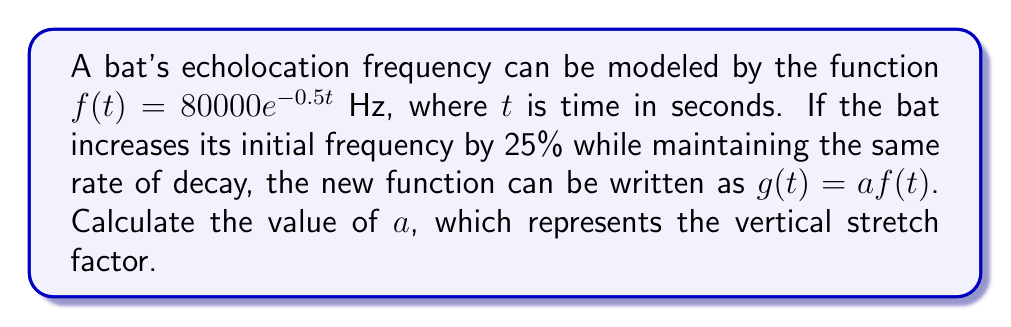What is the answer to this math problem? To solve this problem, we'll follow these steps:

1) The original function is $f(t) = 80000e^{-0.5t}$ Hz.

2) The new function $g(t)$ is a vertical stretch of $f(t)$, represented as $g(t) = af(t)$.

3) We're told that the initial frequency is increased by 25%. This means that at $t=0$, the new function value is 125% of the original function value.

4) Let's calculate the initial value of $f(t)$:
   $f(0) = 80000e^{-0.5(0)} = 80000$ Hz

5) The initial value of $g(t)$ should be 125% of this:
   $g(0) = 1.25 \times 80000 = 100000$ Hz

6) Now, we can set up an equation:
   $g(0) = af(0)$
   $100000 = a(80000)$

7) Solving for $a$:
   $a = \frac{100000}{80000} = \frac{5}{4} = 1.25$

Therefore, the vertical stretch factor $a$ is 1.25.
Answer: $a = 1.25$ 